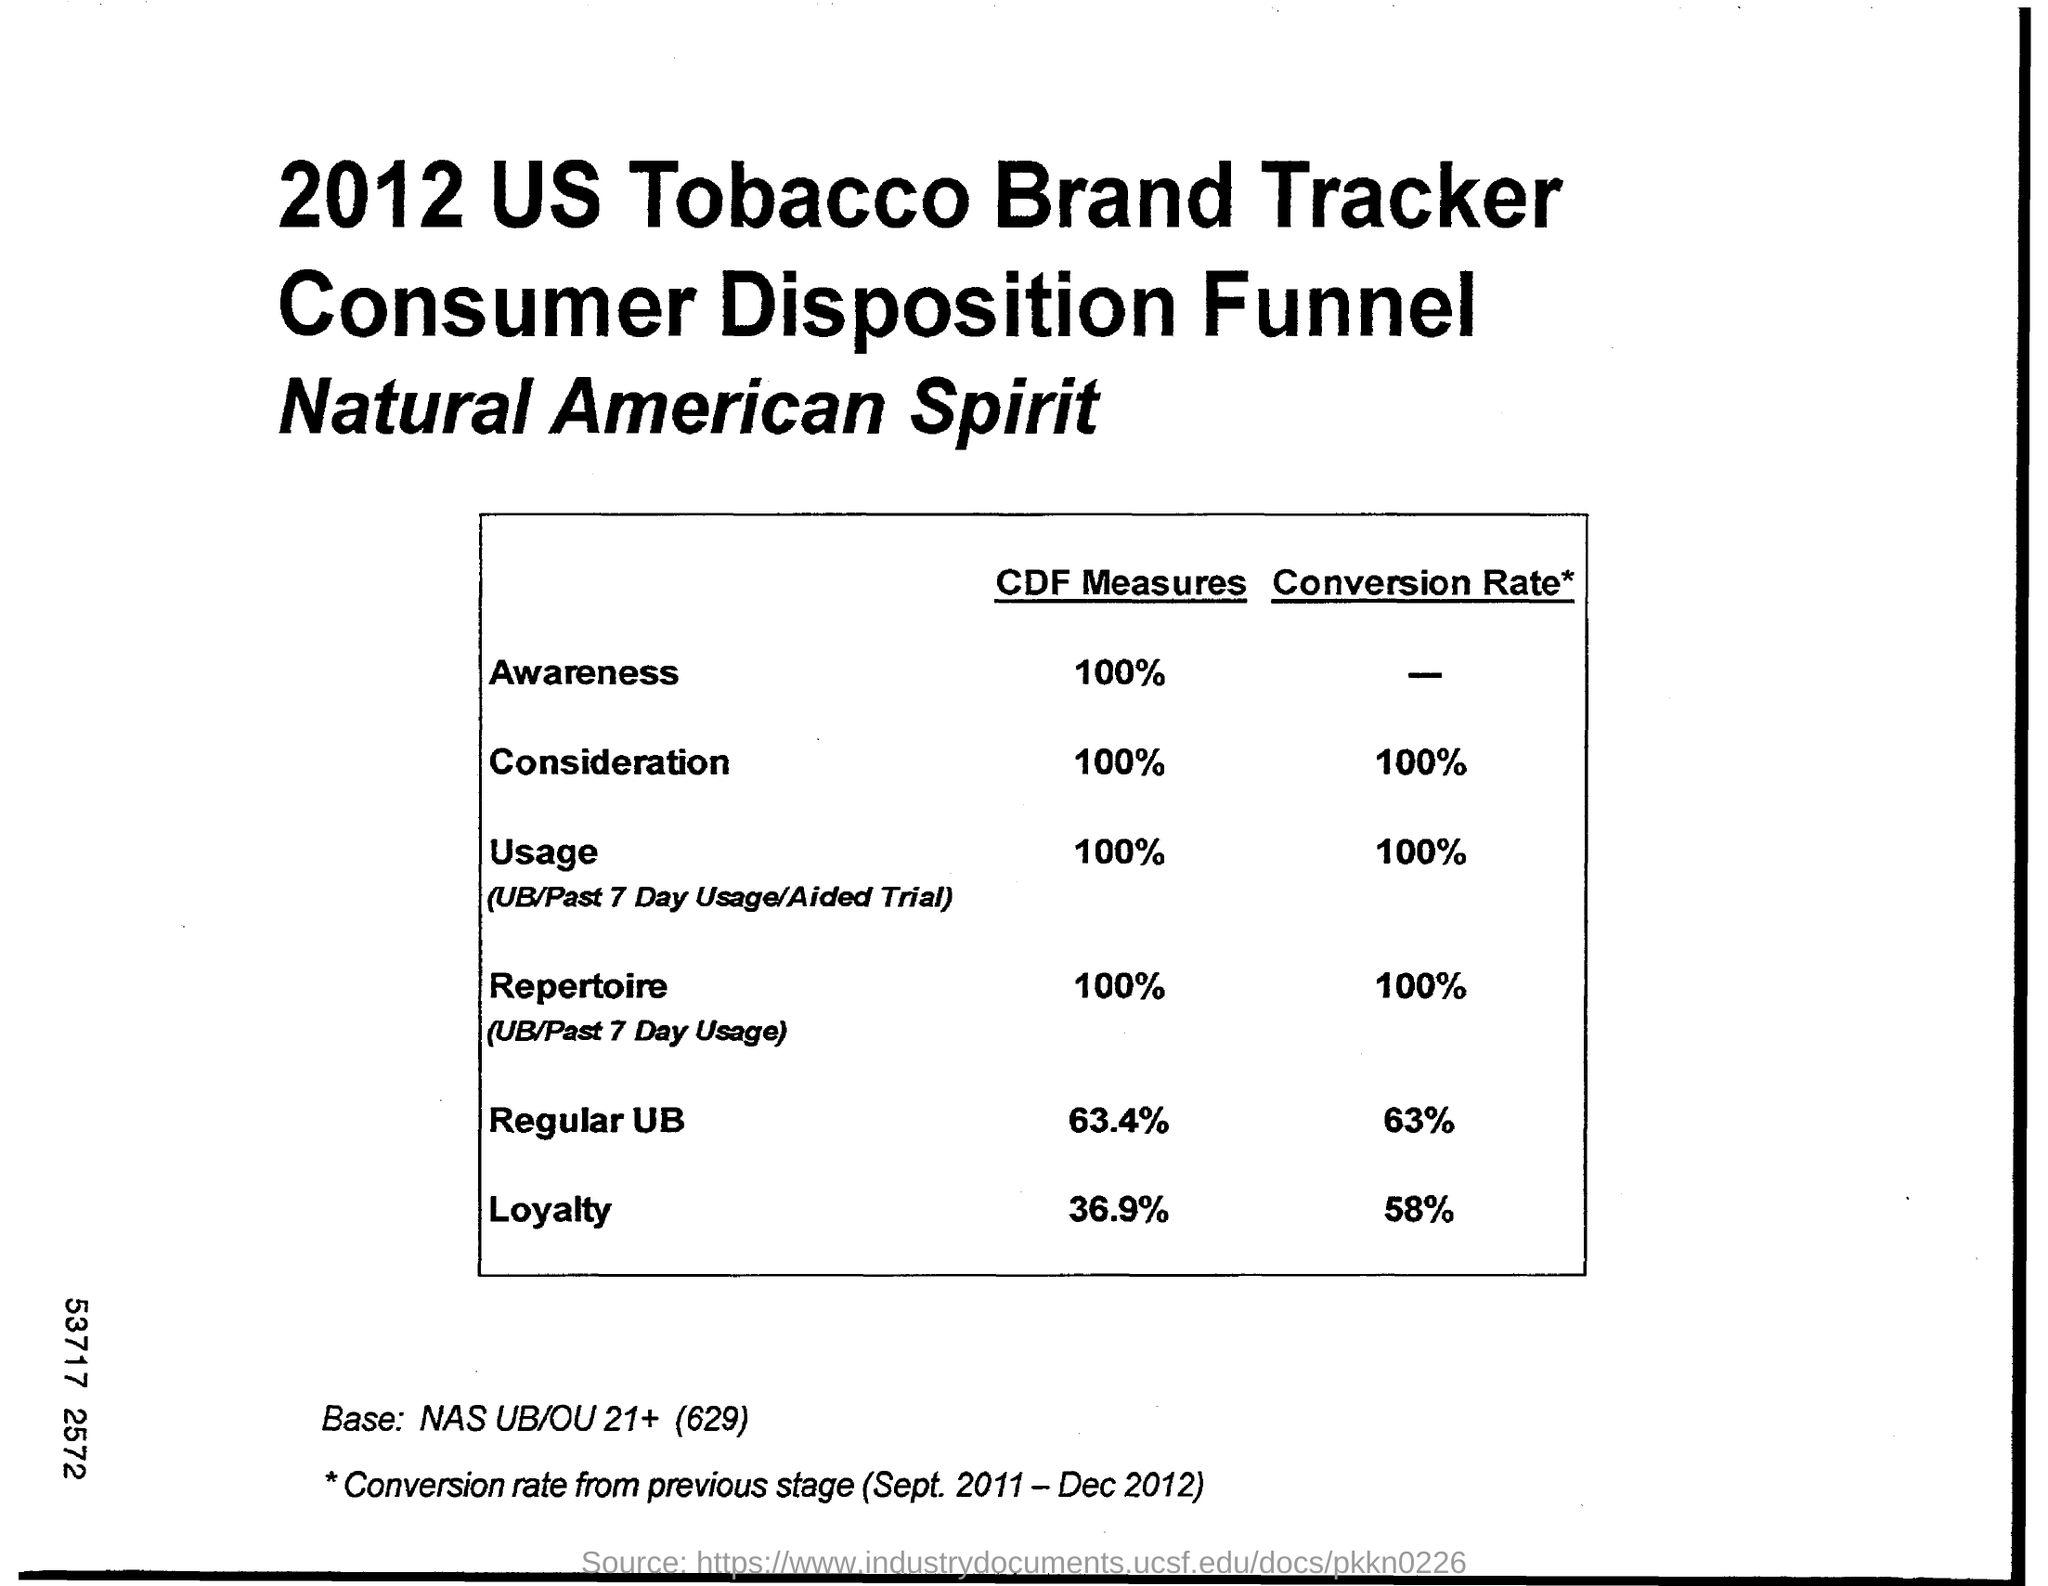Point out several critical features in this image. According to the CDF measures, the percentage of loyalty is 36.9%. 